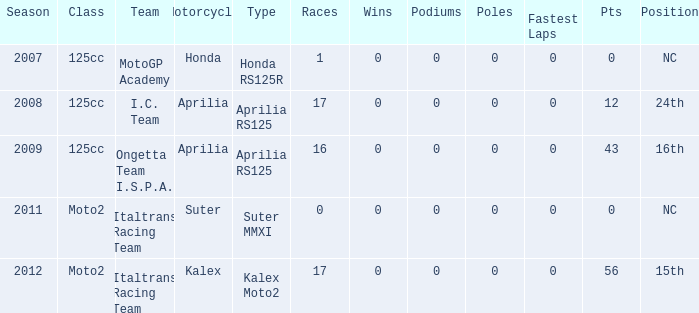With 0 points, what class does italtrans racing team belong to? Moto2. Could you parse the entire table as a dict? {'header': ['Season', 'Class', 'Team', 'Motorcycle', 'Type', 'Races', 'Wins', 'Podiums', 'Poles', 'Fastest Laps', 'Pts', 'Position'], 'rows': [['2007', '125cc', 'MotoGP Academy', 'Honda', 'Honda RS125R', '1', '0', '0', '0', '0', '0', 'NC'], ['2008', '125cc', 'I.C. Team', 'Aprilia', 'Aprilia RS125', '17', '0', '0', '0', '0', '12', '24th'], ['2009', '125cc', 'Ongetta Team I.S.P.A.', 'Aprilia', 'Aprilia RS125', '16', '0', '0', '0', '0', '43', '16th'], ['2011', 'Moto2', 'Italtrans Racing Team', 'Suter', 'Suter MMXI', '0', '0', '0', '0', '0', '0', 'NC'], ['2012', 'Moto2', 'Italtrans Racing Team', 'Kalex', 'Kalex Moto2', '17', '0', '0', '0', '0', '56', '15th']]} 